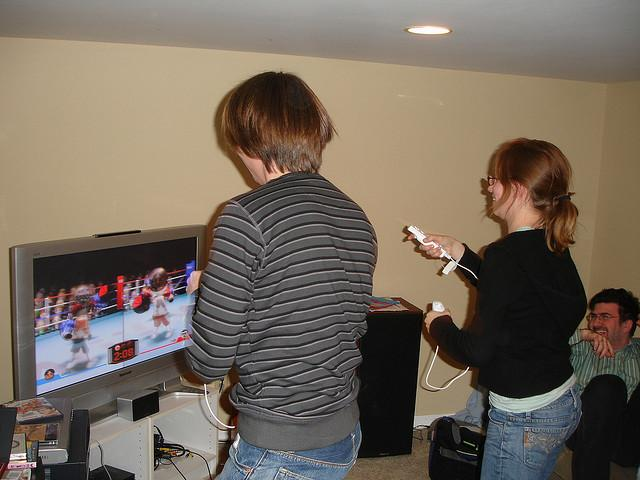What color shirt does the person opposing the wii woman in black? Please explain your reasoning. striped gray. The shirt is striped gray. 